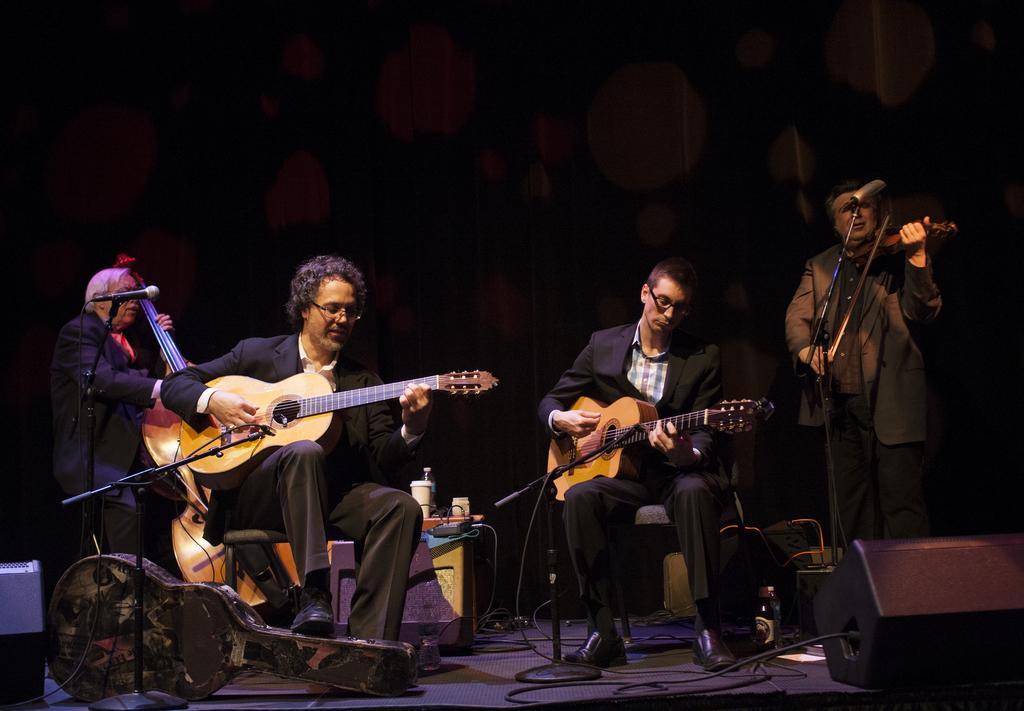Describe this image in one or two sentences. this picture shows four people performing on a dais by playing the musical instruments with the help of a microphone. 